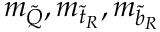<formula> <loc_0><loc_0><loc_500><loc_500>m _ { \tilde { Q } } , m _ { { \tilde { t } } _ { R } } , m _ { { \tilde { b } } _ { R } }</formula> 